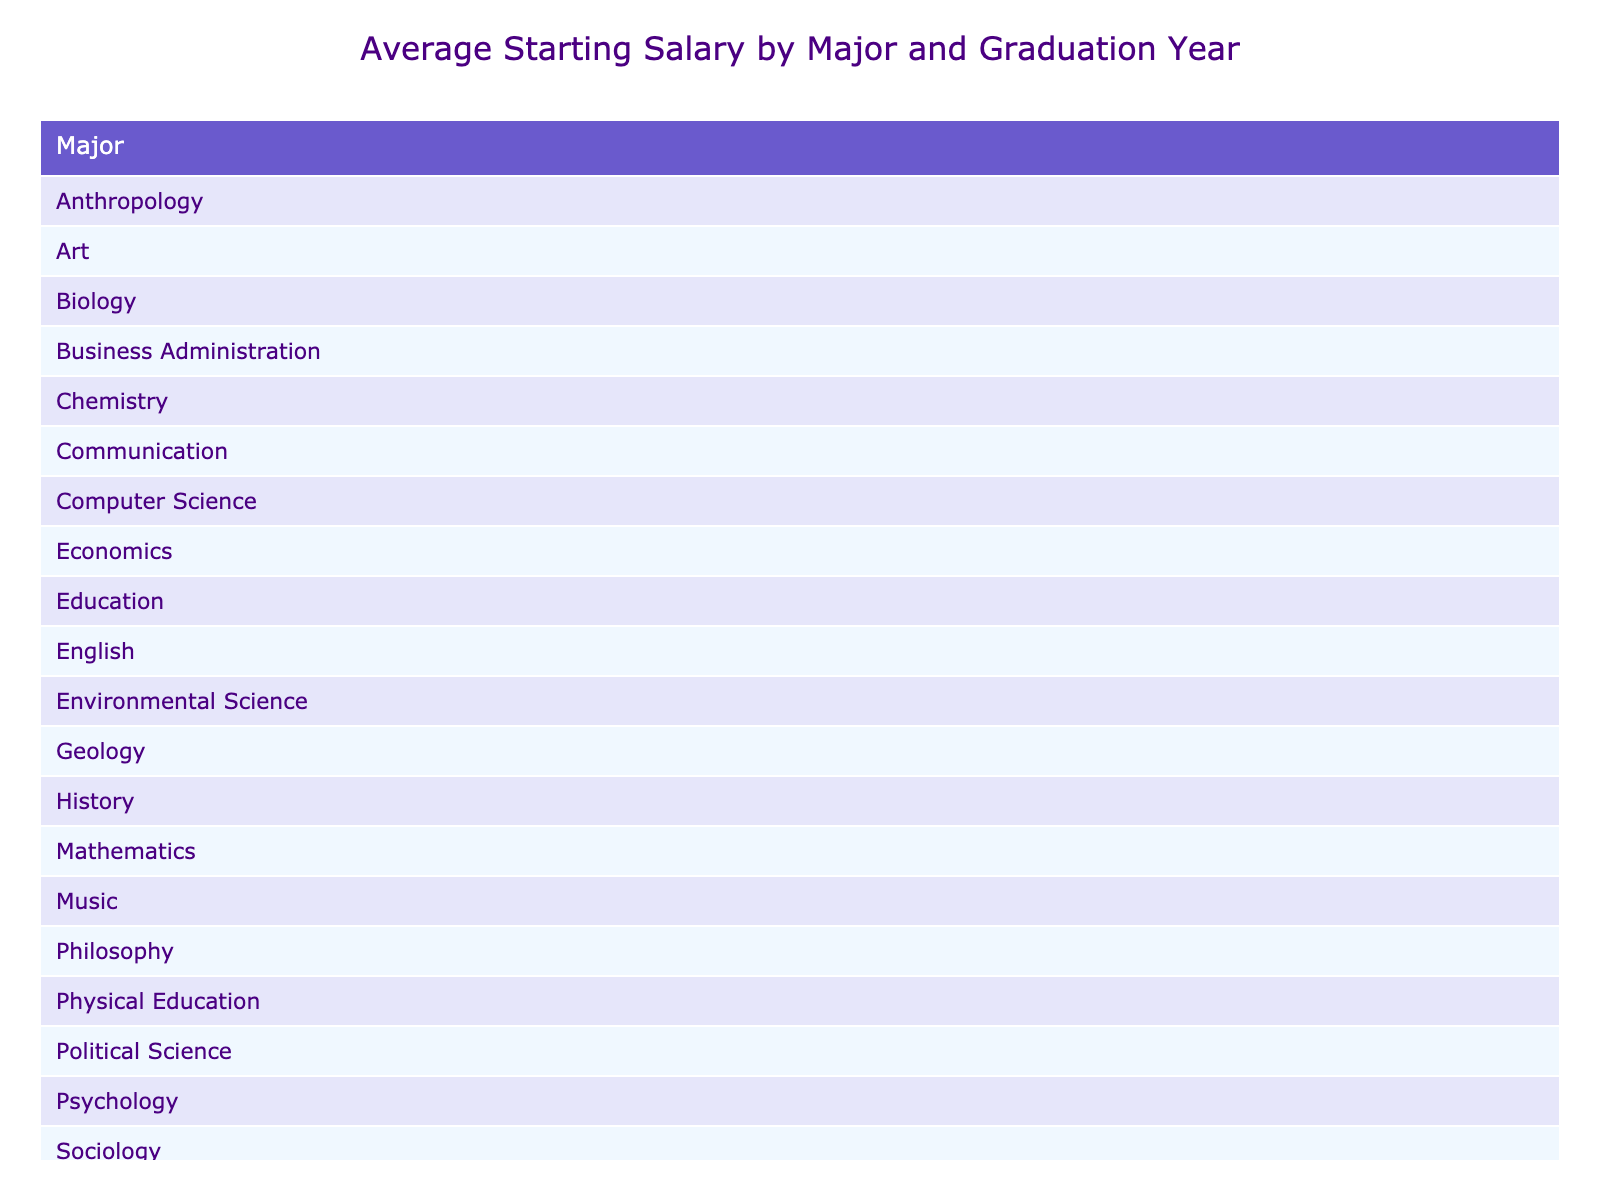What was the highest average starting salary for a graduate in 1978? The highest average starting salary in 1978 was for Philosophy, which was $11,000. This can be verified by looking at the corresponding column for the year 1978 and comparing the values.
Answer: $11,000 Which major had the lowest average starting salary in 1970? In 1970, the average starting salary for Physical Education was $7,000, which is lower than the other majors listed for that graduation year. Thus, Physical Education has the lowest average.
Answer: $7,000 What is the difference between the highest and lowest starting salary in 1975? The highest starting salary in 1975 was $10,500 for Geology, while the lowest was $9,500 for Chemistry. The difference is calculated as $10,500 - $9,500 = $1,000.
Answer: $1,000 Was the average starting salary for English graduates higher than that for Psychology graduates in 1972? English graduates had an average starting salary of $8,200, while Psychology graduates had $7,800 in 1972. Therefore, English graduates earned more.
Answer: Yes How many majors had an average starting salary above $9,000 in 1977? In 1977, two majors had starting salaries above $9,000: Computer Science at $10,000 and Anthropology at $8,700. Therefore, only Computer Science qualifies.
Answer: 1 If you combine the starting salaries of graduates from the Biology and Communication majors for 1971, what is the total? The starting salary for Biology was $8,900 and for Communication was $8,300. Adding these gives $8,900 + $8,300 = $17,200.
Answer: $17,200 Which major experienced a decrease in average starting salary from 1971 to 1973? Checking the figures, both Biology and History were lower in 1973: Biology went from $8,900 down to $7,500 (History) indicating a decrease.
Answer: Yes Is there any major that had the same starting salary in 1976 and 1978? The starting salary for Political Science in 1976 was $8,800, while no other major's starting salary matched that amount in 1978. Thus, there is none.
Answer: No What was the average starting salary for graduates in 1974? The starting salaries for 1974 are Art at $8,000 and Economics at $9,300. To find the average, we calculate (8,000 + 9,300) / 2 = $8,650.
Answer: $8,650 